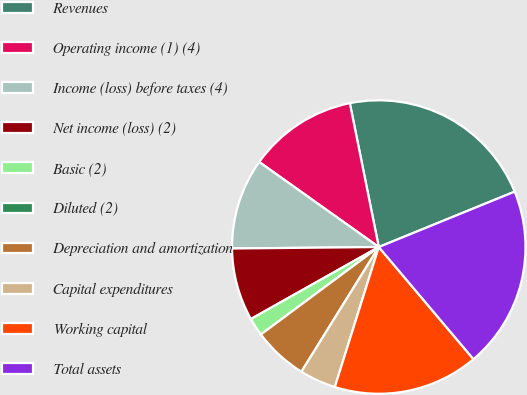Convert chart. <chart><loc_0><loc_0><loc_500><loc_500><pie_chart><fcel>Revenues<fcel>Operating income (1) (4)<fcel>Income (loss) before taxes (4)<fcel>Net income (loss) (2)<fcel>Basic (2)<fcel>Diluted (2)<fcel>Depreciation and amortization<fcel>Capital expenditures<fcel>Working capital<fcel>Total assets<nl><fcel>22.0%<fcel>12.0%<fcel>10.0%<fcel>8.0%<fcel>2.0%<fcel>0.0%<fcel>6.0%<fcel>4.0%<fcel>16.0%<fcel>20.0%<nl></chart> 